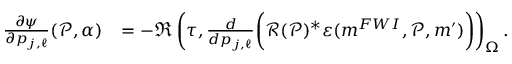<formula> <loc_0><loc_0><loc_500><loc_500>\begin{array} { r l } { \frac { \partial \psi } { \partial p _ { j , \ell } } ( \mathcal { P } , \alpha ) } & { = - \Re \left ( \tau , \frac { d } { d p _ { j , \ell } } \left ( \mathcal { R } ( \mathcal { P } ) ^ { * } \varepsilon ( m ^ { F W I } , \mathcal { P } , m ^ { \prime } ) \right ) \right ) _ { \Omega } . } \end{array}</formula> 